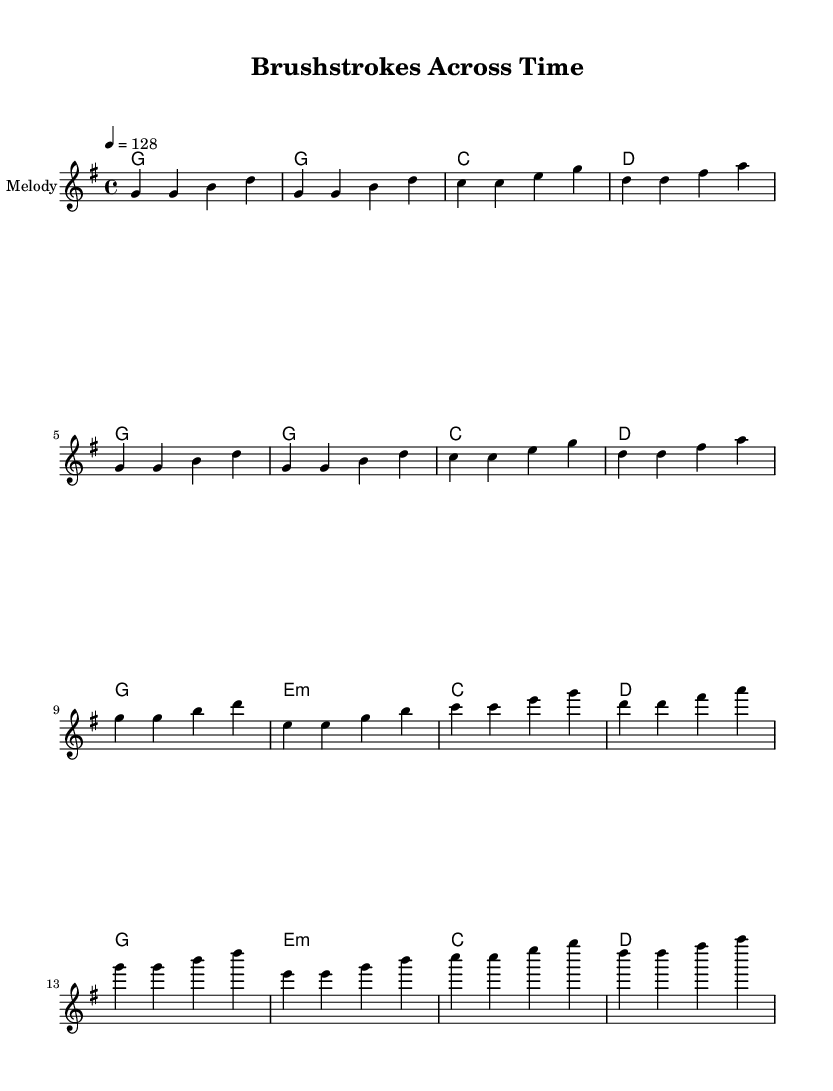What is the key signature of this music? The key signature is G major, which has one sharp (F#). This is indicated at the beginning of the music sheet.
Answer: G major What is the time signature of the piece? The time signature is 4/4, which is shown at the start of the score. This means there are four beats in a measure and a quarter note receives one beat.
Answer: 4/4 What is the tempo marking for the song? The tempo is marked as 128, which means the quarter note is played at a speed of 128 beats per minute. This is typically indicated by the tempo notation at the beginning of the music.
Answer: 128 How many verses are in the song? There are two verses in the song, as indicated by the lyrics structure provided before the chorus. Each verse is followed by the chorus, and the arrangement shows a repeat of the verses.
Answer: 2 What is the first chord of the chorus? The first chord of the chorus is E minor, which is shown in the chord progression in the score. This implies a shift in harmony that complements the lyrical content of the chorus.
Answer: E minor What does the title "Brushstrokes Across Time" suggest about the song's theme? The title suggests a theme of blending and connecting different cultural influences, likely referring to the interaction of East Asian art and Renaissance European art, which is a focus of the lyrics. This thematic connection is reflected in the content of the song itself.
Answer: Cultural blending 